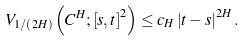Convert formula to latex. <formula><loc_0><loc_0><loc_500><loc_500>V _ { 1 / \left ( 2 H \right ) } \left ( C ^ { H } ; \left [ s , t \right ] ^ { 2 } \right ) \leq c _ { H } \left | t - s \right | ^ { 2 H } .</formula> 